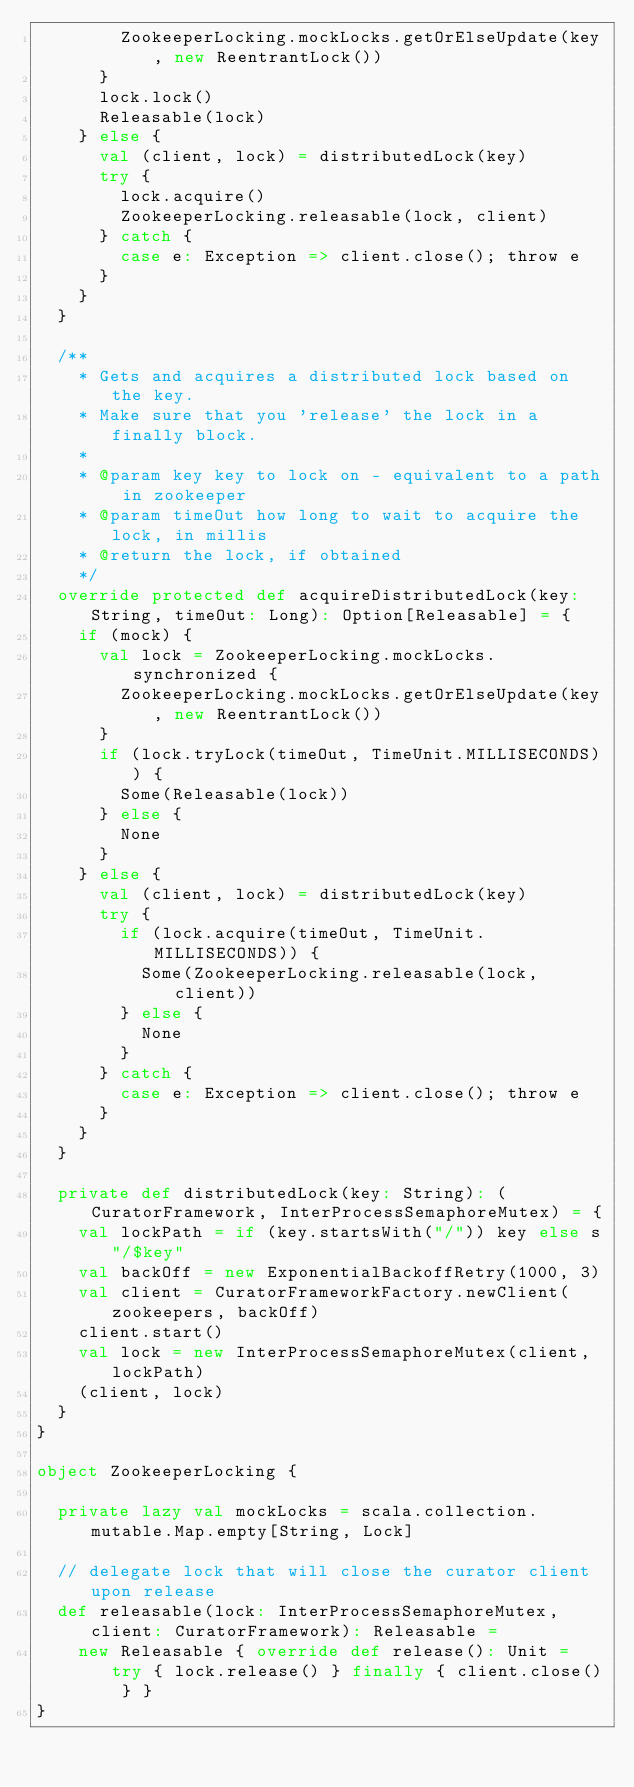Convert code to text. <code><loc_0><loc_0><loc_500><loc_500><_Scala_>        ZookeeperLocking.mockLocks.getOrElseUpdate(key, new ReentrantLock())
      }
      lock.lock()
      Releasable(lock)
    } else {
      val (client, lock) = distributedLock(key)
      try {
        lock.acquire()
        ZookeeperLocking.releasable(lock, client)
      } catch {
        case e: Exception => client.close(); throw e
      }
    }
  }

  /**
    * Gets and acquires a distributed lock based on the key.
    * Make sure that you 'release' the lock in a finally block.
    *
    * @param key key to lock on - equivalent to a path in zookeeper
    * @param timeOut how long to wait to acquire the lock, in millis
    * @return the lock, if obtained
    */
  override protected def acquireDistributedLock(key: String, timeOut: Long): Option[Releasable] = {
    if (mock) {
      val lock = ZookeeperLocking.mockLocks.synchronized {
        ZookeeperLocking.mockLocks.getOrElseUpdate(key, new ReentrantLock())
      }
      if (lock.tryLock(timeOut, TimeUnit.MILLISECONDS)) {
        Some(Releasable(lock))
      } else {
        None
      }
    } else {
      val (client, lock) = distributedLock(key)
      try {
        if (lock.acquire(timeOut, TimeUnit.MILLISECONDS)) {
          Some(ZookeeperLocking.releasable(lock, client))
        } else {
          None
        }
      } catch {
        case e: Exception => client.close(); throw e
      }
    }
  }

  private def distributedLock(key: String): (CuratorFramework, InterProcessSemaphoreMutex) = {
    val lockPath = if (key.startsWith("/")) key else s"/$key"
    val backOff = new ExponentialBackoffRetry(1000, 3)
    val client = CuratorFrameworkFactory.newClient(zookeepers, backOff)
    client.start()
    val lock = new InterProcessSemaphoreMutex(client, lockPath)
    (client, lock)
  }
}

object ZookeeperLocking {

  private lazy val mockLocks = scala.collection.mutable.Map.empty[String, Lock]

  // delegate lock that will close the curator client upon release
  def releasable(lock: InterProcessSemaphoreMutex, client: CuratorFramework): Releasable =
    new Releasable { override def release(): Unit = try { lock.release() } finally { client.close() } }
}
</code> 